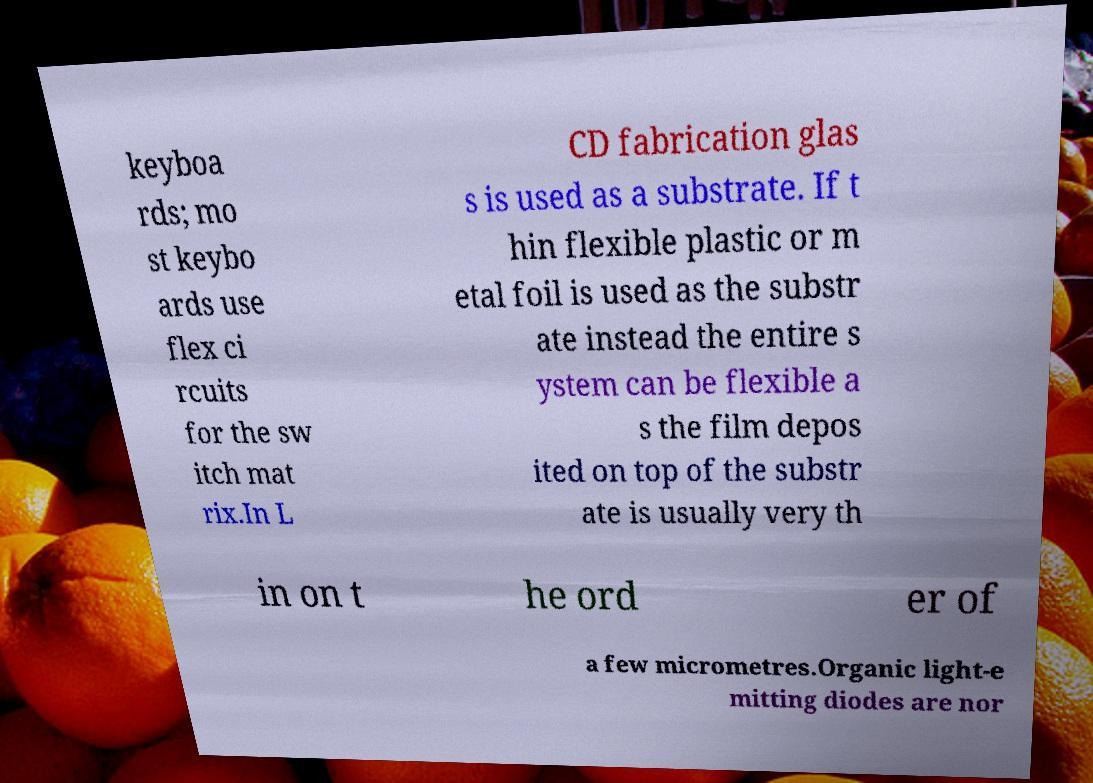Please read and relay the text visible in this image. What does it say? keyboa rds; mo st keybo ards use flex ci rcuits for the sw itch mat rix.In L CD fabrication glas s is used as a substrate. If t hin flexible plastic or m etal foil is used as the substr ate instead the entire s ystem can be flexible a s the film depos ited on top of the substr ate is usually very th in on t he ord er of a few micrometres.Organic light-e mitting diodes are nor 